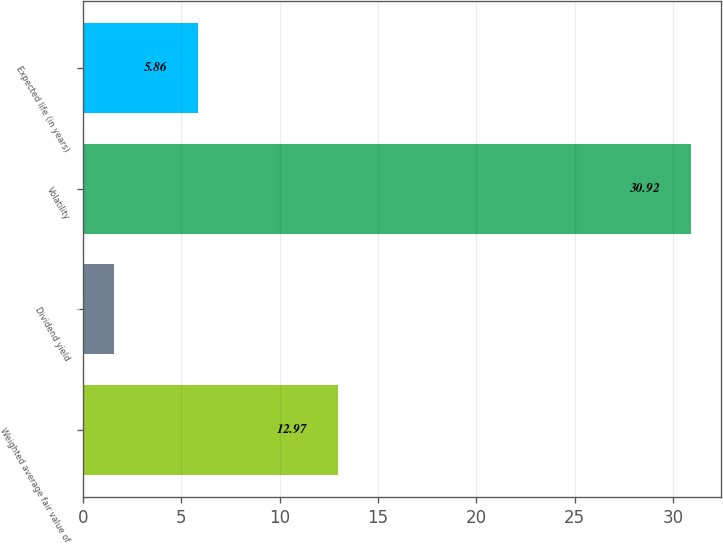<chart> <loc_0><loc_0><loc_500><loc_500><bar_chart><fcel>Weighted average fair value of<fcel>Dividend yield<fcel>Volatility<fcel>Expected life (in years)<nl><fcel>12.97<fcel>1.57<fcel>30.92<fcel>5.86<nl></chart> 